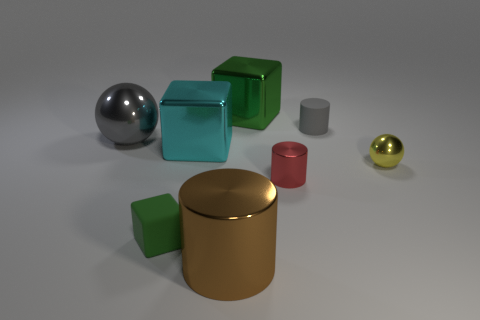Subtract all purple cylinders. How many green cubes are left? 2 Subtract 1 cylinders. How many cylinders are left? 2 Add 1 rubber objects. How many objects exist? 9 Subtract 0 purple cylinders. How many objects are left? 8 Subtract all cylinders. How many objects are left? 5 Subtract all matte objects. Subtract all big gray objects. How many objects are left? 5 Add 1 rubber cylinders. How many rubber cylinders are left? 2 Add 5 gray objects. How many gray objects exist? 7 